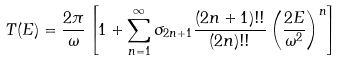<formula> <loc_0><loc_0><loc_500><loc_500>T ( E ) = \frac { 2 \pi } { \omega } \left [ 1 + \sum _ { n = 1 } ^ { \infty } \sigma _ { 2 n + 1 } \frac { ( 2 n + 1 ) ! ! } { ( 2 n ) ! ! } \left ( \frac { 2 E } { \omega ^ { 2 } } \right ) ^ { n } \right ]</formula> 